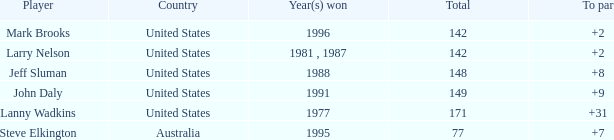Name the To par that has a Year(s) won of 1988 and a Total smaller than 148? None. 